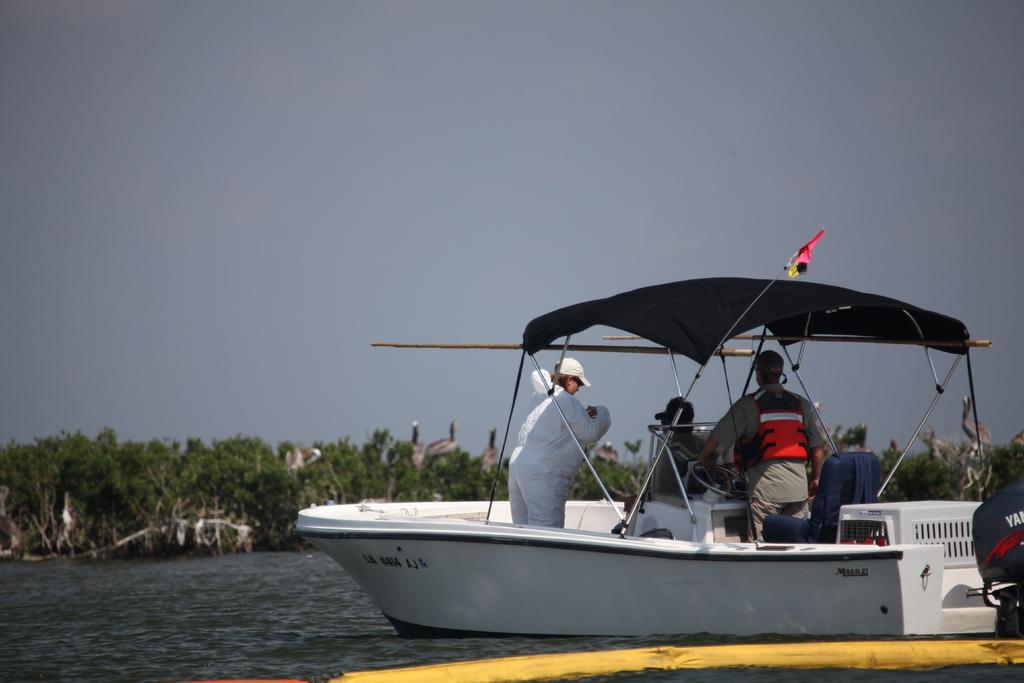Please provide a concise description of this image. In this image we can see people in boat. At the bottom of the image there is water. In the background of the image there are trees, sky. 